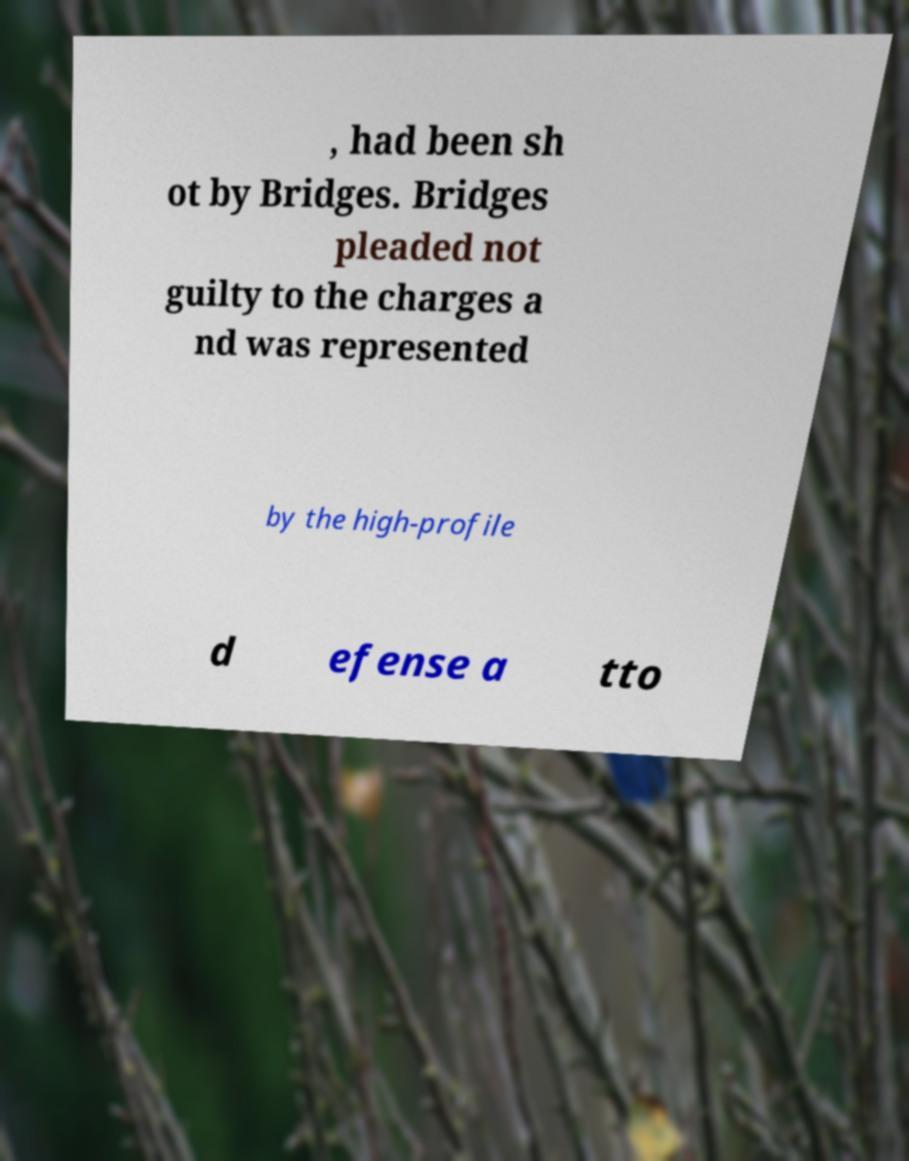Can you read and provide the text displayed in the image?This photo seems to have some interesting text. Can you extract and type it out for me? , had been sh ot by Bridges. Bridges pleaded not guilty to the charges a nd was represented by the high-profile d efense a tto 